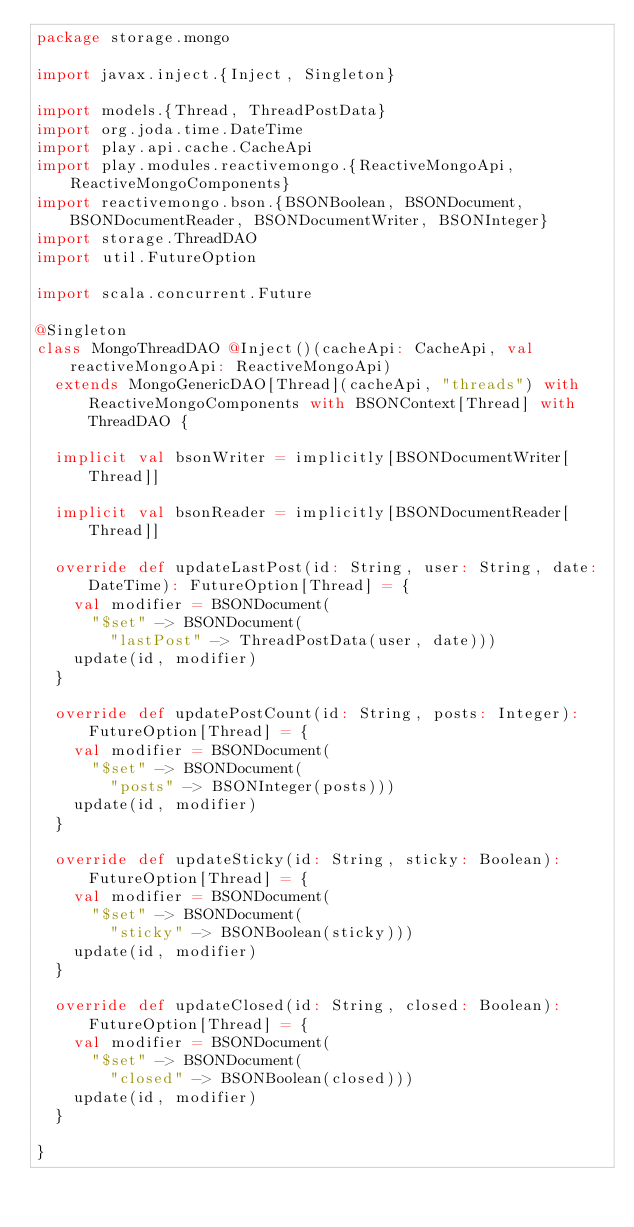<code> <loc_0><loc_0><loc_500><loc_500><_Scala_>package storage.mongo

import javax.inject.{Inject, Singleton}

import models.{Thread, ThreadPostData}
import org.joda.time.DateTime
import play.api.cache.CacheApi
import play.modules.reactivemongo.{ReactiveMongoApi, ReactiveMongoComponents}
import reactivemongo.bson.{BSONBoolean, BSONDocument, BSONDocumentReader, BSONDocumentWriter, BSONInteger}
import storage.ThreadDAO
import util.FutureOption

import scala.concurrent.Future

@Singleton
class MongoThreadDAO @Inject()(cacheApi: CacheApi, val reactiveMongoApi: ReactiveMongoApi)
  extends MongoGenericDAO[Thread](cacheApi, "threads") with ReactiveMongoComponents with BSONContext[Thread] with ThreadDAO {

  implicit val bsonWriter = implicitly[BSONDocumentWriter[Thread]]

  implicit val bsonReader = implicitly[BSONDocumentReader[Thread]]

  override def updateLastPost(id: String, user: String, date: DateTime): FutureOption[Thread] = {
    val modifier = BSONDocument(
      "$set" -> BSONDocument(
        "lastPost" -> ThreadPostData(user, date)))
    update(id, modifier)
  }

  override def updatePostCount(id: String, posts: Integer): FutureOption[Thread] = {
    val modifier = BSONDocument(
      "$set" -> BSONDocument(
        "posts" -> BSONInteger(posts)))
    update(id, modifier)
  }

  override def updateSticky(id: String, sticky: Boolean): FutureOption[Thread] = {
    val modifier = BSONDocument(
      "$set" -> BSONDocument(
        "sticky" -> BSONBoolean(sticky)))
    update(id, modifier)
  }

  override def updateClosed(id: String, closed: Boolean): FutureOption[Thread] = {
    val modifier = BSONDocument(
      "$set" -> BSONDocument(
        "closed" -> BSONBoolean(closed)))
    update(id, modifier)
  }

}
</code> 